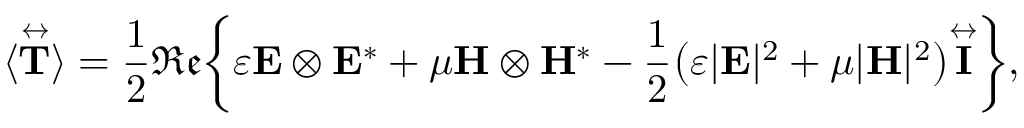<formula> <loc_0><loc_0><loc_500><loc_500>\langle \overset { \leftrightarrow } T } \rangle = \frac { 1 } { 2 } \mathfrak { R e } \left \{ \varepsilon E \otimes E ^ { * } + \mu H \otimes H ^ { * } - \frac { 1 } { 2 } \left ( \varepsilon | E | ^ { 2 } + \mu | H | ^ { 2 } \right ) \overset { \leftrightarrow } I } \right \} ,</formula> 